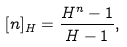<formula> <loc_0><loc_0><loc_500><loc_500>[ n ] _ { H } = \frac { H ^ { n } - 1 } { H - 1 } ,</formula> 